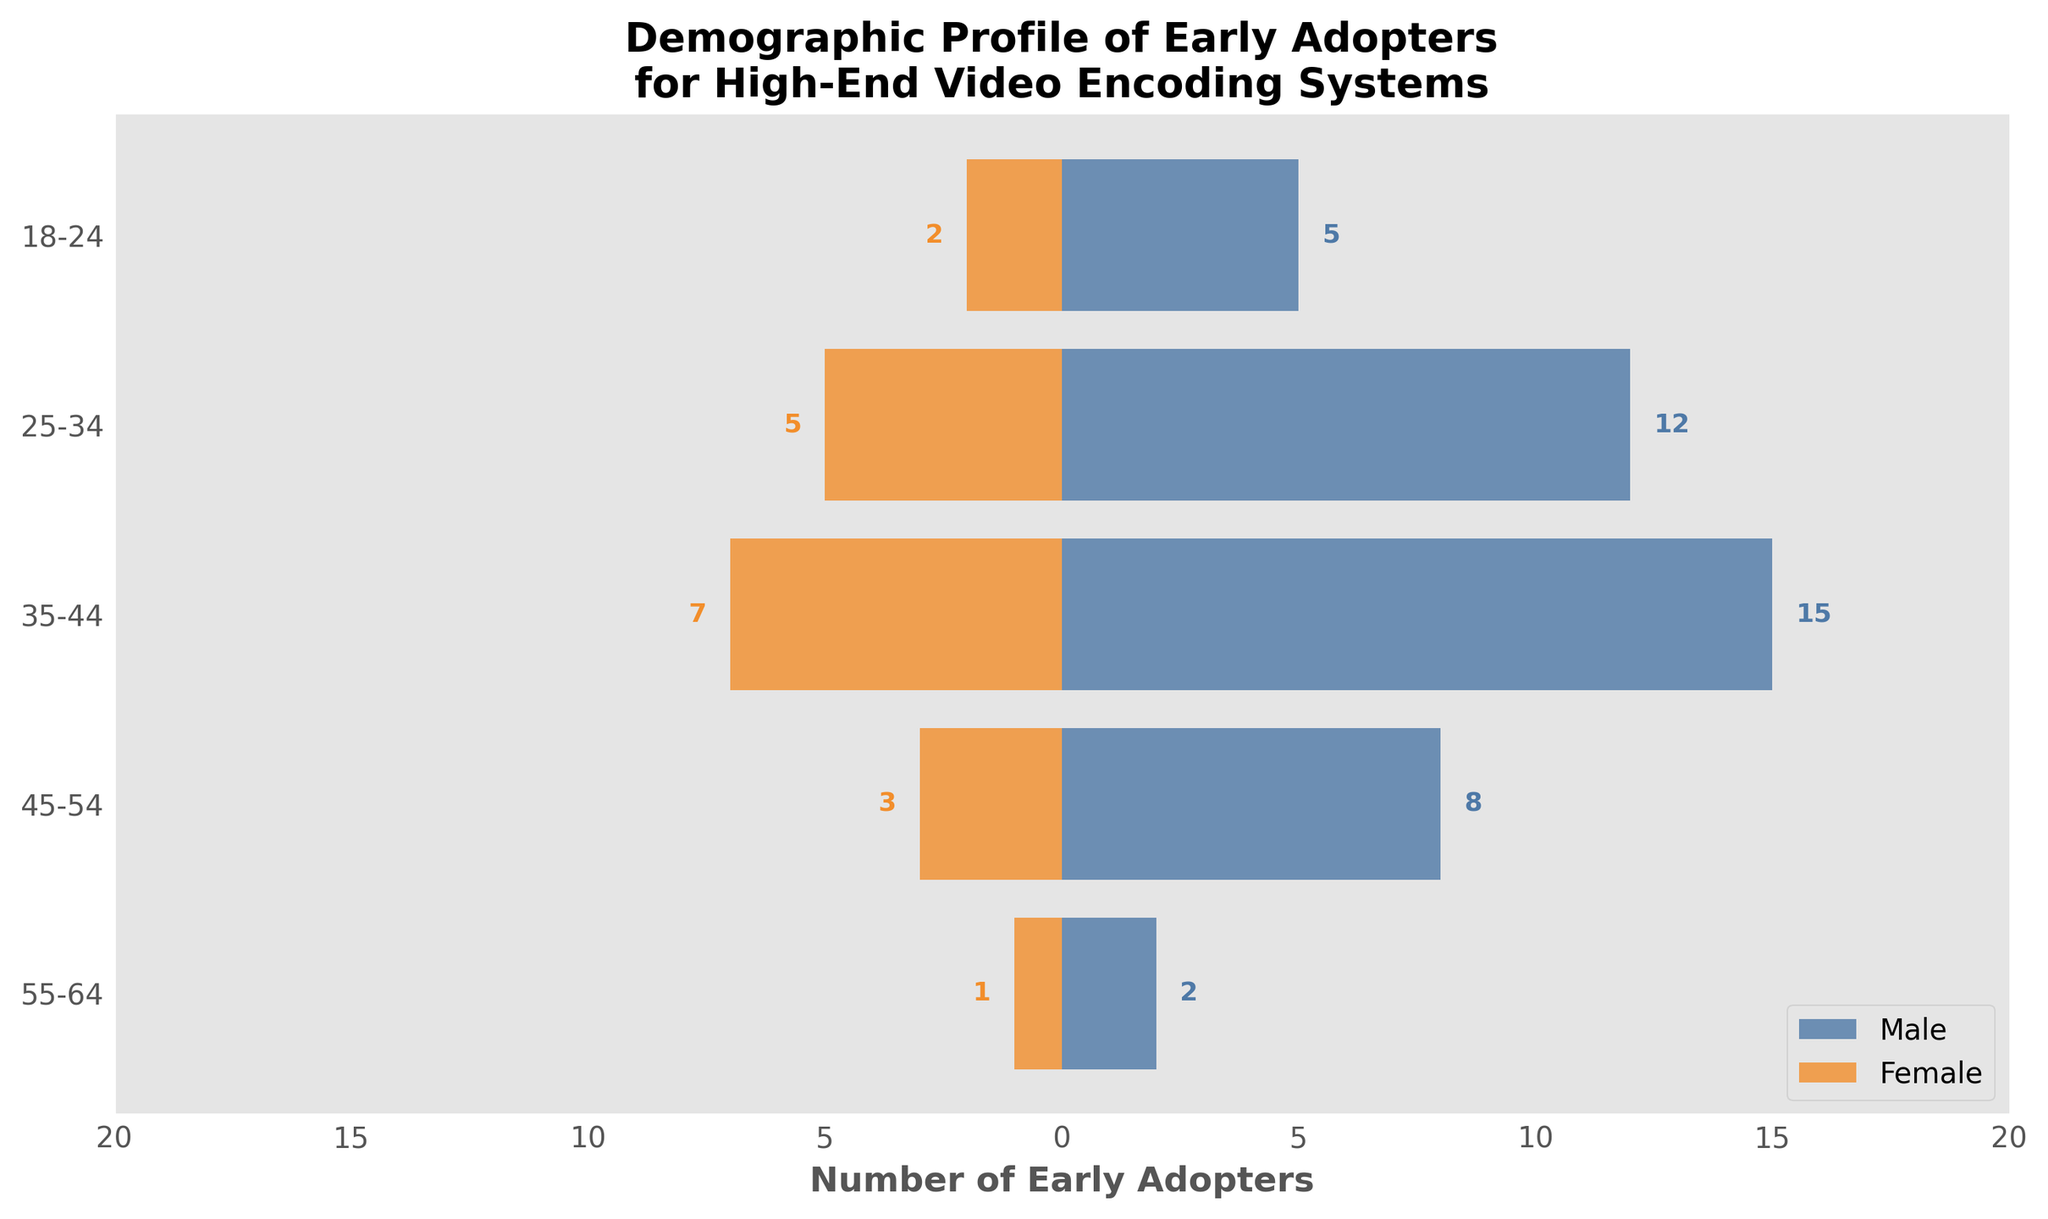How many early adopters are there in the 35-44 age group? Look at the bar lengths for the 35-44 age group. The Male bar extends to 15, and the Female bar extends to -7 (but the magnitude is 7). Adding these together, we get 15 (Male) + 7 (Female) = 22 adopters.
Answer: 22 In which age group do males show the highest number of early adopters? Examine the bar lengths for all the age groups, focusing on the Male bars. The 35-44 age group has the longest Male bar, indicating 15 early adopters.
Answer: 35-44 Compare the number of female early adopters in the 25-34 age group to those in the 45-54 age group. The Female bar for the 25-34 age group extends to -5 (5 adopters), whereas for the 45-54 age group, it extends to -3 (3 adopters). 5 is greater than 3.
Answer: 25-34 group has more What is the total number of early adopters across all age groups? Sum the total number of Male and Female adopters in each age group: (2+1) + (8+3) + (15+7) + (12+5) + (5+2) = 48
Answer: 48 Which gender has more early adopters in the 45-54 age group? The Male bar for the 45-54 age group extends to 8, whereas the Female bar extends to -3. 8 is greater than 3.
Answer: Male What is the average number of female early adopters across all age groups? Sum up the Female adopters first: 1 + 3 + 7 + 5 + 2 = 18. There are 5 age groups, so the average is 18 / 5 = 3.6
Answer: 3.6 How many more male early adopters are there compared to female early adopters in the 25-34 age group? For the 25-34 age group, there are 12 Male adopters and 5 Female adopters. The difference is 12 - 5 = 7.
Answer: 7 Identify the age group with the smallest total number of early adopters. Calculate the total number of adopters in each age group: 55-64 (3), 45-54 (11), 35-44 (22), 25-34 (17), 18-24 (7). The smallest number is in the 55-64 group.
Answer: 55-64 What proportion of the early adopters in the 35-44 age group are female? In the 35-44 age group, there are 15 Male and 7 Female. The total is 22. The proportion of Females is 7 / 22 ≈ 0.318.
Answer: ~0.318 